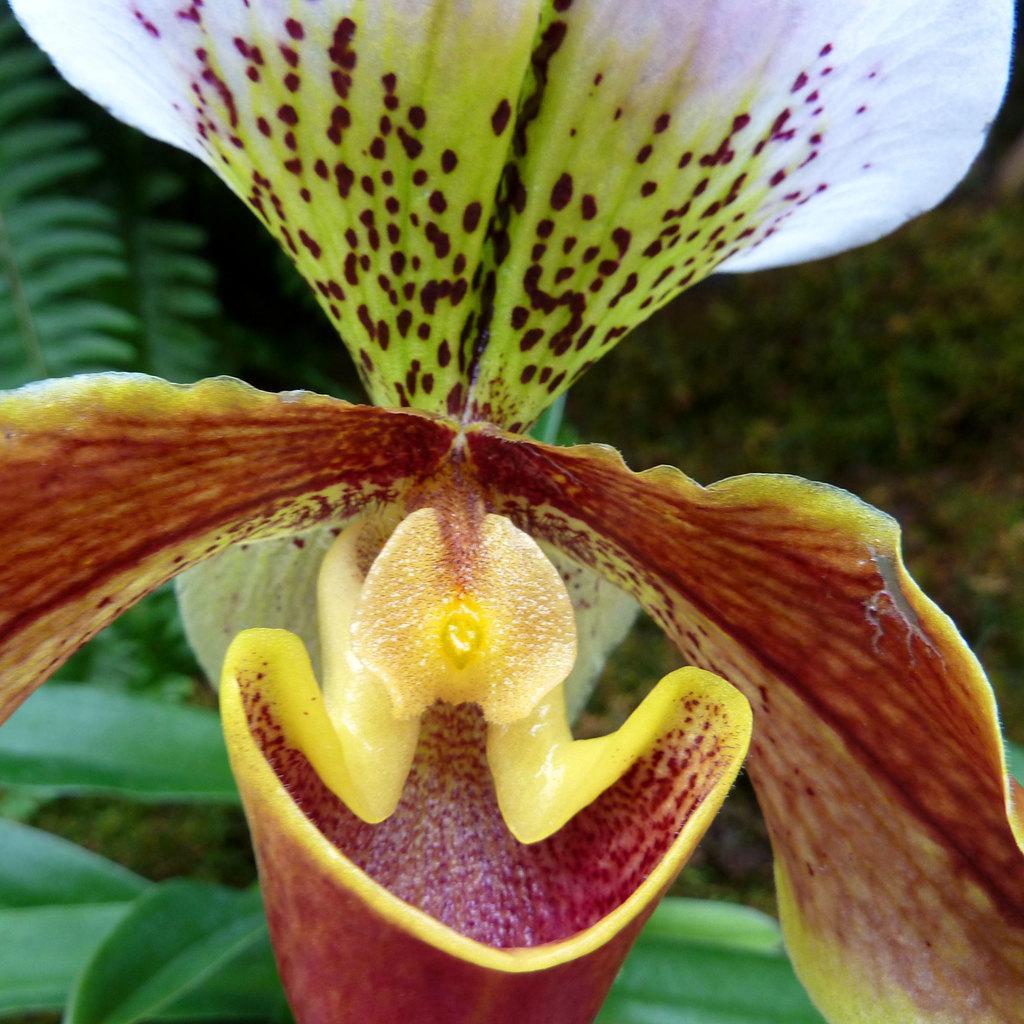How would you summarize this image in a sentence or two? In this image I can see a flower which are of white, green and brown in colour. In background I can see few green colour leaves and I can see this image is little bit blurry from background. 